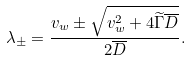Convert formula to latex. <formula><loc_0><loc_0><loc_500><loc_500>\lambda _ { \pm } = \frac { v _ { w } \pm \sqrt { v _ { w } ^ { 2 } + 4 \widetilde { \Gamma } \overline { D } } } { 2 \overline { D } } .</formula> 